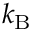<formula> <loc_0><loc_0><loc_500><loc_500>k _ { B }</formula> 